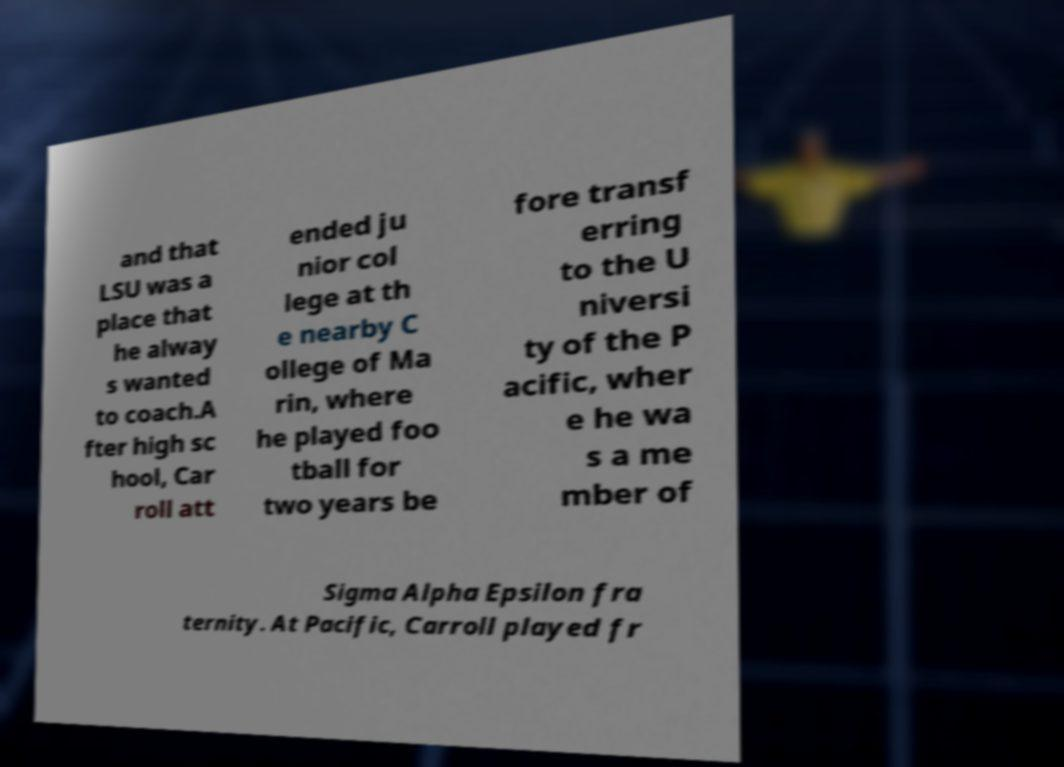For documentation purposes, I need the text within this image transcribed. Could you provide that? and that LSU was a place that he alway s wanted to coach.A fter high sc hool, Car roll att ended ju nior col lege at th e nearby C ollege of Ma rin, where he played foo tball for two years be fore transf erring to the U niversi ty of the P acific, wher e he wa s a me mber of Sigma Alpha Epsilon fra ternity. At Pacific, Carroll played fr 